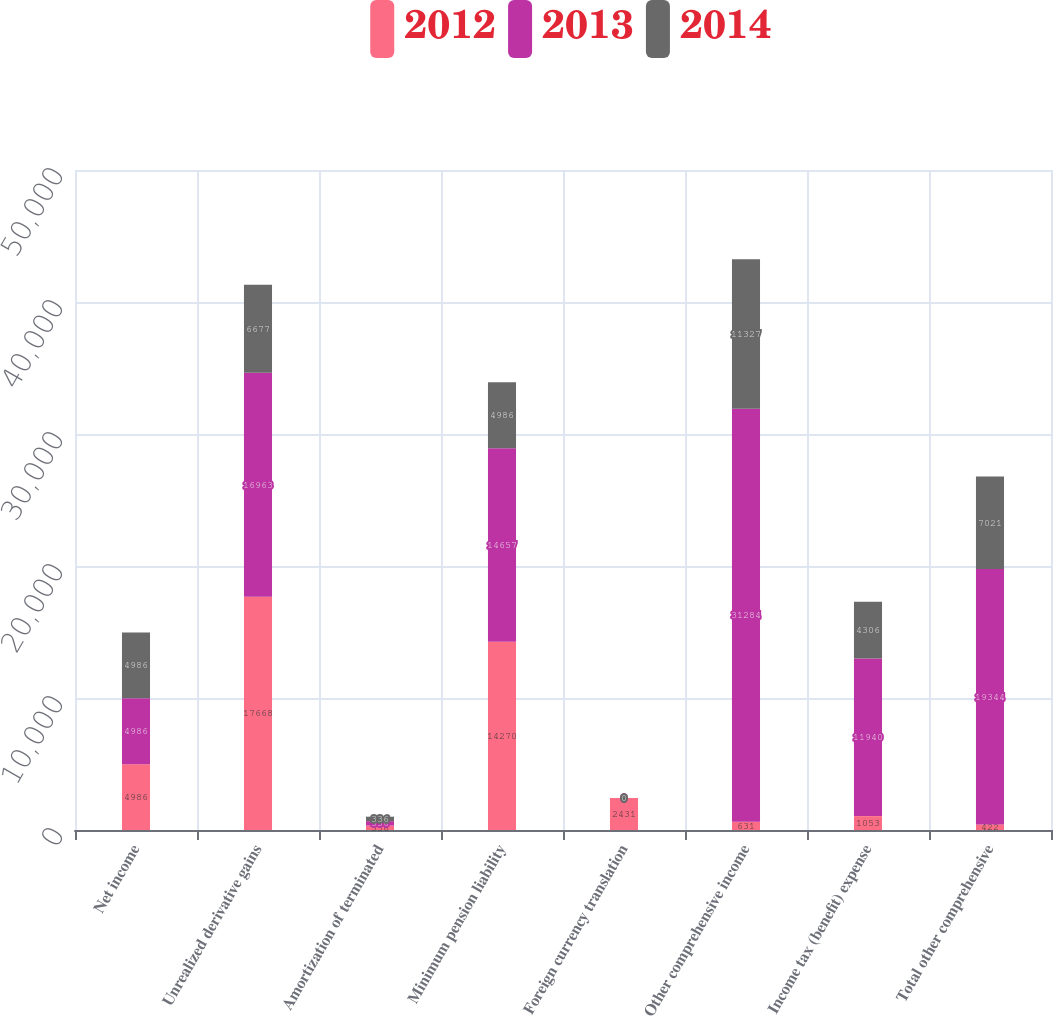<chart> <loc_0><loc_0><loc_500><loc_500><stacked_bar_chart><ecel><fcel>Net income<fcel>Unrealized derivative gains<fcel>Amortization of terminated<fcel>Minimum pension liability<fcel>Foreign currency translation<fcel>Other comprehensive income<fcel>Income tax (benefit) expense<fcel>Total other comprehensive<nl><fcel>2012<fcel>4986<fcel>17668<fcel>336<fcel>14270<fcel>2431<fcel>631<fcel>1053<fcel>422<nl><fcel>2013<fcel>4986<fcel>16963<fcel>336<fcel>14657<fcel>0<fcel>31284<fcel>11940<fcel>19344<nl><fcel>2014<fcel>4986<fcel>6677<fcel>336<fcel>4986<fcel>0<fcel>11327<fcel>4306<fcel>7021<nl></chart> 